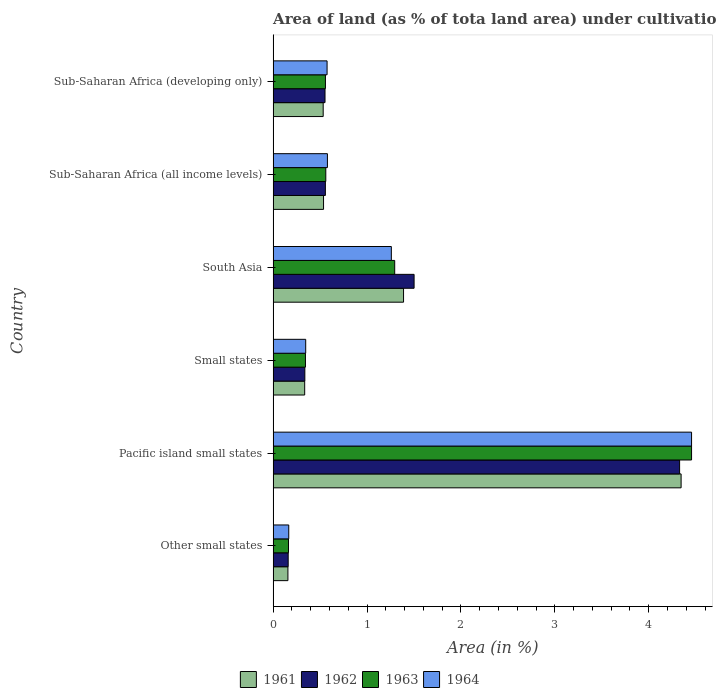How many different coloured bars are there?
Your response must be concise. 4. How many bars are there on the 6th tick from the bottom?
Offer a terse response. 4. What is the label of the 5th group of bars from the top?
Keep it short and to the point. Pacific island small states. What is the percentage of land under cultivation in 1962 in Other small states?
Your response must be concise. 0.16. Across all countries, what is the maximum percentage of land under cultivation in 1963?
Give a very brief answer. 4.46. Across all countries, what is the minimum percentage of land under cultivation in 1961?
Your answer should be very brief. 0.16. In which country was the percentage of land under cultivation in 1961 maximum?
Offer a terse response. Pacific island small states. In which country was the percentage of land under cultivation in 1964 minimum?
Your answer should be compact. Other small states. What is the total percentage of land under cultivation in 1961 in the graph?
Make the answer very short. 7.3. What is the difference between the percentage of land under cultivation in 1964 in Pacific island small states and that in Small states?
Make the answer very short. 4.11. What is the difference between the percentage of land under cultivation in 1961 in Sub-Saharan Africa (all income levels) and the percentage of land under cultivation in 1963 in Other small states?
Your answer should be compact. 0.37. What is the average percentage of land under cultivation in 1964 per country?
Offer a very short reply. 1.23. What is the difference between the percentage of land under cultivation in 1964 and percentage of land under cultivation in 1961 in Sub-Saharan Africa (all income levels)?
Provide a succinct answer. 0.04. What is the ratio of the percentage of land under cultivation in 1964 in Other small states to that in Pacific island small states?
Offer a terse response. 0.04. Is the percentage of land under cultivation in 1964 in Pacific island small states less than that in South Asia?
Ensure brevity in your answer.  No. What is the difference between the highest and the second highest percentage of land under cultivation in 1961?
Give a very brief answer. 2.96. What is the difference between the highest and the lowest percentage of land under cultivation in 1964?
Offer a very short reply. 4.29. In how many countries, is the percentage of land under cultivation in 1962 greater than the average percentage of land under cultivation in 1962 taken over all countries?
Provide a short and direct response. 2. What does the 4th bar from the top in Pacific island small states represents?
Offer a very short reply. 1961. What does the 2nd bar from the bottom in Small states represents?
Provide a short and direct response. 1962. Is it the case that in every country, the sum of the percentage of land under cultivation in 1964 and percentage of land under cultivation in 1963 is greater than the percentage of land under cultivation in 1961?
Your answer should be compact. Yes. How many bars are there?
Provide a short and direct response. 24. Are all the bars in the graph horizontal?
Keep it short and to the point. Yes. How many countries are there in the graph?
Give a very brief answer. 6. What is the difference between two consecutive major ticks on the X-axis?
Provide a short and direct response. 1. Are the values on the major ticks of X-axis written in scientific E-notation?
Provide a succinct answer. No. How many legend labels are there?
Give a very brief answer. 4. What is the title of the graph?
Your answer should be compact. Area of land (as % of tota land area) under cultivation. Does "1966" appear as one of the legend labels in the graph?
Give a very brief answer. No. What is the label or title of the X-axis?
Your answer should be very brief. Area (in %). What is the label or title of the Y-axis?
Ensure brevity in your answer.  Country. What is the Area (in %) of 1961 in Other small states?
Offer a very short reply. 0.16. What is the Area (in %) in 1962 in Other small states?
Provide a short and direct response. 0.16. What is the Area (in %) in 1963 in Other small states?
Offer a very short reply. 0.16. What is the Area (in %) in 1964 in Other small states?
Provide a succinct answer. 0.17. What is the Area (in %) in 1961 in Pacific island small states?
Provide a succinct answer. 4.34. What is the Area (in %) of 1962 in Pacific island small states?
Your response must be concise. 4.33. What is the Area (in %) in 1963 in Pacific island small states?
Give a very brief answer. 4.46. What is the Area (in %) in 1964 in Pacific island small states?
Provide a succinct answer. 4.46. What is the Area (in %) of 1961 in Small states?
Provide a short and direct response. 0.34. What is the Area (in %) in 1962 in Small states?
Offer a very short reply. 0.34. What is the Area (in %) in 1963 in Small states?
Give a very brief answer. 0.34. What is the Area (in %) of 1964 in Small states?
Provide a succinct answer. 0.35. What is the Area (in %) in 1961 in South Asia?
Offer a very short reply. 1.39. What is the Area (in %) of 1962 in South Asia?
Make the answer very short. 1.5. What is the Area (in %) in 1963 in South Asia?
Keep it short and to the point. 1.29. What is the Area (in %) of 1964 in South Asia?
Make the answer very short. 1.26. What is the Area (in %) in 1961 in Sub-Saharan Africa (all income levels)?
Keep it short and to the point. 0.54. What is the Area (in %) of 1962 in Sub-Saharan Africa (all income levels)?
Your answer should be compact. 0.56. What is the Area (in %) in 1963 in Sub-Saharan Africa (all income levels)?
Make the answer very short. 0.56. What is the Area (in %) of 1964 in Sub-Saharan Africa (all income levels)?
Offer a very short reply. 0.58. What is the Area (in %) of 1961 in Sub-Saharan Africa (developing only)?
Ensure brevity in your answer.  0.53. What is the Area (in %) in 1962 in Sub-Saharan Africa (developing only)?
Make the answer very short. 0.55. What is the Area (in %) in 1963 in Sub-Saharan Africa (developing only)?
Give a very brief answer. 0.56. What is the Area (in %) in 1964 in Sub-Saharan Africa (developing only)?
Your answer should be compact. 0.57. Across all countries, what is the maximum Area (in %) of 1961?
Make the answer very short. 4.34. Across all countries, what is the maximum Area (in %) of 1962?
Provide a succinct answer. 4.33. Across all countries, what is the maximum Area (in %) in 1963?
Make the answer very short. 4.46. Across all countries, what is the maximum Area (in %) in 1964?
Your answer should be compact. 4.46. Across all countries, what is the minimum Area (in %) of 1961?
Keep it short and to the point. 0.16. Across all countries, what is the minimum Area (in %) of 1962?
Keep it short and to the point. 0.16. Across all countries, what is the minimum Area (in %) of 1963?
Your answer should be very brief. 0.16. Across all countries, what is the minimum Area (in %) of 1964?
Give a very brief answer. 0.17. What is the total Area (in %) of 1961 in the graph?
Your answer should be compact. 7.3. What is the total Area (in %) in 1962 in the graph?
Offer a terse response. 7.44. What is the total Area (in %) in 1963 in the graph?
Offer a terse response. 7.38. What is the total Area (in %) of 1964 in the graph?
Keep it short and to the point. 7.38. What is the difference between the Area (in %) of 1961 in Other small states and that in Pacific island small states?
Your answer should be very brief. -4.19. What is the difference between the Area (in %) of 1962 in Other small states and that in Pacific island small states?
Provide a short and direct response. -4.17. What is the difference between the Area (in %) in 1963 in Other small states and that in Pacific island small states?
Your response must be concise. -4.29. What is the difference between the Area (in %) of 1964 in Other small states and that in Pacific island small states?
Give a very brief answer. -4.29. What is the difference between the Area (in %) of 1961 in Other small states and that in Small states?
Offer a very short reply. -0.18. What is the difference between the Area (in %) of 1962 in Other small states and that in Small states?
Give a very brief answer. -0.18. What is the difference between the Area (in %) in 1963 in Other small states and that in Small states?
Your answer should be very brief. -0.18. What is the difference between the Area (in %) in 1964 in Other small states and that in Small states?
Offer a terse response. -0.18. What is the difference between the Area (in %) of 1961 in Other small states and that in South Asia?
Keep it short and to the point. -1.23. What is the difference between the Area (in %) of 1962 in Other small states and that in South Asia?
Your answer should be very brief. -1.34. What is the difference between the Area (in %) in 1963 in Other small states and that in South Asia?
Your answer should be very brief. -1.13. What is the difference between the Area (in %) of 1964 in Other small states and that in South Asia?
Keep it short and to the point. -1.09. What is the difference between the Area (in %) in 1961 in Other small states and that in Sub-Saharan Africa (all income levels)?
Ensure brevity in your answer.  -0.38. What is the difference between the Area (in %) of 1962 in Other small states and that in Sub-Saharan Africa (all income levels)?
Make the answer very short. -0.4. What is the difference between the Area (in %) of 1963 in Other small states and that in Sub-Saharan Africa (all income levels)?
Offer a very short reply. -0.4. What is the difference between the Area (in %) of 1964 in Other small states and that in Sub-Saharan Africa (all income levels)?
Your answer should be compact. -0.41. What is the difference between the Area (in %) of 1961 in Other small states and that in Sub-Saharan Africa (developing only)?
Offer a terse response. -0.38. What is the difference between the Area (in %) of 1962 in Other small states and that in Sub-Saharan Africa (developing only)?
Your response must be concise. -0.39. What is the difference between the Area (in %) of 1963 in Other small states and that in Sub-Saharan Africa (developing only)?
Your answer should be compact. -0.39. What is the difference between the Area (in %) of 1964 in Other small states and that in Sub-Saharan Africa (developing only)?
Provide a succinct answer. -0.41. What is the difference between the Area (in %) in 1961 in Pacific island small states and that in Small states?
Provide a short and direct response. 4.01. What is the difference between the Area (in %) of 1962 in Pacific island small states and that in Small states?
Make the answer very short. 3.99. What is the difference between the Area (in %) of 1963 in Pacific island small states and that in Small states?
Ensure brevity in your answer.  4.11. What is the difference between the Area (in %) in 1964 in Pacific island small states and that in Small states?
Make the answer very short. 4.11. What is the difference between the Area (in %) in 1961 in Pacific island small states and that in South Asia?
Your response must be concise. 2.96. What is the difference between the Area (in %) in 1962 in Pacific island small states and that in South Asia?
Your response must be concise. 2.83. What is the difference between the Area (in %) in 1963 in Pacific island small states and that in South Asia?
Your answer should be very brief. 3.16. What is the difference between the Area (in %) in 1964 in Pacific island small states and that in South Asia?
Your response must be concise. 3.2. What is the difference between the Area (in %) in 1961 in Pacific island small states and that in Sub-Saharan Africa (all income levels)?
Offer a very short reply. 3.81. What is the difference between the Area (in %) in 1962 in Pacific island small states and that in Sub-Saharan Africa (all income levels)?
Provide a short and direct response. 3.77. What is the difference between the Area (in %) of 1963 in Pacific island small states and that in Sub-Saharan Africa (all income levels)?
Ensure brevity in your answer.  3.89. What is the difference between the Area (in %) in 1964 in Pacific island small states and that in Sub-Saharan Africa (all income levels)?
Keep it short and to the point. 3.88. What is the difference between the Area (in %) of 1961 in Pacific island small states and that in Sub-Saharan Africa (developing only)?
Your answer should be very brief. 3.81. What is the difference between the Area (in %) in 1962 in Pacific island small states and that in Sub-Saharan Africa (developing only)?
Give a very brief answer. 3.78. What is the difference between the Area (in %) in 1963 in Pacific island small states and that in Sub-Saharan Africa (developing only)?
Make the answer very short. 3.9. What is the difference between the Area (in %) of 1964 in Pacific island small states and that in Sub-Saharan Africa (developing only)?
Offer a very short reply. 3.88. What is the difference between the Area (in %) of 1961 in Small states and that in South Asia?
Provide a succinct answer. -1.05. What is the difference between the Area (in %) of 1962 in Small states and that in South Asia?
Offer a terse response. -1.16. What is the difference between the Area (in %) in 1963 in Small states and that in South Asia?
Ensure brevity in your answer.  -0.95. What is the difference between the Area (in %) of 1964 in Small states and that in South Asia?
Your answer should be very brief. -0.91. What is the difference between the Area (in %) of 1961 in Small states and that in Sub-Saharan Africa (all income levels)?
Offer a terse response. -0.2. What is the difference between the Area (in %) in 1962 in Small states and that in Sub-Saharan Africa (all income levels)?
Your answer should be compact. -0.22. What is the difference between the Area (in %) in 1963 in Small states and that in Sub-Saharan Africa (all income levels)?
Your response must be concise. -0.22. What is the difference between the Area (in %) of 1964 in Small states and that in Sub-Saharan Africa (all income levels)?
Give a very brief answer. -0.23. What is the difference between the Area (in %) of 1961 in Small states and that in Sub-Saharan Africa (developing only)?
Your answer should be very brief. -0.2. What is the difference between the Area (in %) of 1962 in Small states and that in Sub-Saharan Africa (developing only)?
Make the answer very short. -0.21. What is the difference between the Area (in %) in 1963 in Small states and that in Sub-Saharan Africa (developing only)?
Keep it short and to the point. -0.21. What is the difference between the Area (in %) of 1964 in Small states and that in Sub-Saharan Africa (developing only)?
Your answer should be compact. -0.23. What is the difference between the Area (in %) in 1961 in South Asia and that in Sub-Saharan Africa (all income levels)?
Offer a terse response. 0.85. What is the difference between the Area (in %) of 1962 in South Asia and that in Sub-Saharan Africa (all income levels)?
Provide a succinct answer. 0.94. What is the difference between the Area (in %) of 1963 in South Asia and that in Sub-Saharan Africa (all income levels)?
Ensure brevity in your answer.  0.73. What is the difference between the Area (in %) of 1964 in South Asia and that in Sub-Saharan Africa (all income levels)?
Your answer should be very brief. 0.68. What is the difference between the Area (in %) of 1961 in South Asia and that in Sub-Saharan Africa (developing only)?
Offer a terse response. 0.86. What is the difference between the Area (in %) in 1962 in South Asia and that in Sub-Saharan Africa (developing only)?
Offer a terse response. 0.95. What is the difference between the Area (in %) in 1963 in South Asia and that in Sub-Saharan Africa (developing only)?
Offer a very short reply. 0.74. What is the difference between the Area (in %) of 1964 in South Asia and that in Sub-Saharan Africa (developing only)?
Ensure brevity in your answer.  0.68. What is the difference between the Area (in %) of 1961 in Sub-Saharan Africa (all income levels) and that in Sub-Saharan Africa (developing only)?
Provide a succinct answer. 0. What is the difference between the Area (in %) of 1962 in Sub-Saharan Africa (all income levels) and that in Sub-Saharan Africa (developing only)?
Your answer should be very brief. 0. What is the difference between the Area (in %) of 1963 in Sub-Saharan Africa (all income levels) and that in Sub-Saharan Africa (developing only)?
Provide a succinct answer. 0. What is the difference between the Area (in %) of 1964 in Sub-Saharan Africa (all income levels) and that in Sub-Saharan Africa (developing only)?
Your response must be concise. 0. What is the difference between the Area (in %) in 1961 in Other small states and the Area (in %) in 1962 in Pacific island small states?
Offer a very short reply. -4.17. What is the difference between the Area (in %) of 1961 in Other small states and the Area (in %) of 1963 in Pacific island small states?
Make the answer very short. -4.3. What is the difference between the Area (in %) of 1961 in Other small states and the Area (in %) of 1964 in Pacific island small states?
Provide a succinct answer. -4.3. What is the difference between the Area (in %) in 1962 in Other small states and the Area (in %) in 1963 in Pacific island small states?
Provide a succinct answer. -4.3. What is the difference between the Area (in %) of 1962 in Other small states and the Area (in %) of 1964 in Pacific island small states?
Your answer should be very brief. -4.3. What is the difference between the Area (in %) of 1963 in Other small states and the Area (in %) of 1964 in Pacific island small states?
Make the answer very short. -4.29. What is the difference between the Area (in %) of 1961 in Other small states and the Area (in %) of 1962 in Small states?
Give a very brief answer. -0.18. What is the difference between the Area (in %) of 1961 in Other small states and the Area (in %) of 1963 in Small states?
Keep it short and to the point. -0.19. What is the difference between the Area (in %) of 1961 in Other small states and the Area (in %) of 1964 in Small states?
Your answer should be compact. -0.19. What is the difference between the Area (in %) of 1962 in Other small states and the Area (in %) of 1963 in Small states?
Offer a very short reply. -0.18. What is the difference between the Area (in %) in 1962 in Other small states and the Area (in %) in 1964 in Small states?
Provide a short and direct response. -0.19. What is the difference between the Area (in %) in 1963 in Other small states and the Area (in %) in 1964 in Small states?
Your response must be concise. -0.18. What is the difference between the Area (in %) of 1961 in Other small states and the Area (in %) of 1962 in South Asia?
Provide a short and direct response. -1.34. What is the difference between the Area (in %) of 1961 in Other small states and the Area (in %) of 1963 in South Asia?
Your answer should be very brief. -1.14. What is the difference between the Area (in %) of 1961 in Other small states and the Area (in %) of 1964 in South Asia?
Make the answer very short. -1.1. What is the difference between the Area (in %) of 1962 in Other small states and the Area (in %) of 1963 in South Asia?
Keep it short and to the point. -1.13. What is the difference between the Area (in %) in 1962 in Other small states and the Area (in %) in 1964 in South Asia?
Make the answer very short. -1.1. What is the difference between the Area (in %) in 1963 in Other small states and the Area (in %) in 1964 in South Asia?
Provide a succinct answer. -1.1. What is the difference between the Area (in %) in 1961 in Other small states and the Area (in %) in 1962 in Sub-Saharan Africa (all income levels)?
Offer a very short reply. -0.4. What is the difference between the Area (in %) in 1961 in Other small states and the Area (in %) in 1963 in Sub-Saharan Africa (all income levels)?
Your response must be concise. -0.4. What is the difference between the Area (in %) in 1961 in Other small states and the Area (in %) in 1964 in Sub-Saharan Africa (all income levels)?
Your answer should be compact. -0.42. What is the difference between the Area (in %) of 1962 in Other small states and the Area (in %) of 1963 in Sub-Saharan Africa (all income levels)?
Give a very brief answer. -0.4. What is the difference between the Area (in %) of 1962 in Other small states and the Area (in %) of 1964 in Sub-Saharan Africa (all income levels)?
Provide a succinct answer. -0.42. What is the difference between the Area (in %) in 1963 in Other small states and the Area (in %) in 1964 in Sub-Saharan Africa (all income levels)?
Provide a succinct answer. -0.41. What is the difference between the Area (in %) in 1961 in Other small states and the Area (in %) in 1962 in Sub-Saharan Africa (developing only)?
Provide a succinct answer. -0.4. What is the difference between the Area (in %) in 1961 in Other small states and the Area (in %) in 1963 in Sub-Saharan Africa (developing only)?
Provide a succinct answer. -0.4. What is the difference between the Area (in %) in 1961 in Other small states and the Area (in %) in 1964 in Sub-Saharan Africa (developing only)?
Make the answer very short. -0.42. What is the difference between the Area (in %) of 1962 in Other small states and the Area (in %) of 1963 in Sub-Saharan Africa (developing only)?
Your response must be concise. -0.4. What is the difference between the Area (in %) of 1962 in Other small states and the Area (in %) of 1964 in Sub-Saharan Africa (developing only)?
Make the answer very short. -0.41. What is the difference between the Area (in %) in 1963 in Other small states and the Area (in %) in 1964 in Sub-Saharan Africa (developing only)?
Make the answer very short. -0.41. What is the difference between the Area (in %) of 1961 in Pacific island small states and the Area (in %) of 1962 in Small states?
Give a very brief answer. 4.01. What is the difference between the Area (in %) of 1961 in Pacific island small states and the Area (in %) of 1963 in Small states?
Ensure brevity in your answer.  4. What is the difference between the Area (in %) of 1961 in Pacific island small states and the Area (in %) of 1964 in Small states?
Give a very brief answer. 4. What is the difference between the Area (in %) of 1962 in Pacific island small states and the Area (in %) of 1963 in Small states?
Give a very brief answer. 3.98. What is the difference between the Area (in %) of 1962 in Pacific island small states and the Area (in %) of 1964 in Small states?
Offer a very short reply. 3.98. What is the difference between the Area (in %) in 1963 in Pacific island small states and the Area (in %) in 1964 in Small states?
Keep it short and to the point. 4.11. What is the difference between the Area (in %) of 1961 in Pacific island small states and the Area (in %) of 1962 in South Asia?
Your answer should be very brief. 2.84. What is the difference between the Area (in %) in 1961 in Pacific island small states and the Area (in %) in 1963 in South Asia?
Offer a terse response. 3.05. What is the difference between the Area (in %) in 1961 in Pacific island small states and the Area (in %) in 1964 in South Asia?
Provide a short and direct response. 3.09. What is the difference between the Area (in %) of 1962 in Pacific island small states and the Area (in %) of 1963 in South Asia?
Offer a terse response. 3.03. What is the difference between the Area (in %) in 1962 in Pacific island small states and the Area (in %) in 1964 in South Asia?
Provide a short and direct response. 3.07. What is the difference between the Area (in %) of 1963 in Pacific island small states and the Area (in %) of 1964 in South Asia?
Your answer should be compact. 3.2. What is the difference between the Area (in %) of 1961 in Pacific island small states and the Area (in %) of 1962 in Sub-Saharan Africa (all income levels)?
Your answer should be very brief. 3.79. What is the difference between the Area (in %) in 1961 in Pacific island small states and the Area (in %) in 1963 in Sub-Saharan Africa (all income levels)?
Your answer should be very brief. 3.78. What is the difference between the Area (in %) in 1961 in Pacific island small states and the Area (in %) in 1964 in Sub-Saharan Africa (all income levels)?
Provide a succinct answer. 3.77. What is the difference between the Area (in %) of 1962 in Pacific island small states and the Area (in %) of 1963 in Sub-Saharan Africa (all income levels)?
Your response must be concise. 3.77. What is the difference between the Area (in %) in 1962 in Pacific island small states and the Area (in %) in 1964 in Sub-Saharan Africa (all income levels)?
Your response must be concise. 3.75. What is the difference between the Area (in %) in 1963 in Pacific island small states and the Area (in %) in 1964 in Sub-Saharan Africa (all income levels)?
Provide a short and direct response. 3.88. What is the difference between the Area (in %) of 1961 in Pacific island small states and the Area (in %) of 1962 in Sub-Saharan Africa (developing only)?
Provide a succinct answer. 3.79. What is the difference between the Area (in %) in 1961 in Pacific island small states and the Area (in %) in 1963 in Sub-Saharan Africa (developing only)?
Make the answer very short. 3.79. What is the difference between the Area (in %) of 1961 in Pacific island small states and the Area (in %) of 1964 in Sub-Saharan Africa (developing only)?
Ensure brevity in your answer.  3.77. What is the difference between the Area (in %) in 1962 in Pacific island small states and the Area (in %) in 1963 in Sub-Saharan Africa (developing only)?
Make the answer very short. 3.77. What is the difference between the Area (in %) of 1962 in Pacific island small states and the Area (in %) of 1964 in Sub-Saharan Africa (developing only)?
Make the answer very short. 3.75. What is the difference between the Area (in %) in 1963 in Pacific island small states and the Area (in %) in 1964 in Sub-Saharan Africa (developing only)?
Offer a terse response. 3.88. What is the difference between the Area (in %) in 1961 in Small states and the Area (in %) in 1962 in South Asia?
Your response must be concise. -1.17. What is the difference between the Area (in %) of 1961 in Small states and the Area (in %) of 1963 in South Asia?
Provide a short and direct response. -0.96. What is the difference between the Area (in %) of 1961 in Small states and the Area (in %) of 1964 in South Asia?
Offer a terse response. -0.92. What is the difference between the Area (in %) of 1962 in Small states and the Area (in %) of 1963 in South Asia?
Make the answer very short. -0.96. What is the difference between the Area (in %) in 1962 in Small states and the Area (in %) in 1964 in South Asia?
Make the answer very short. -0.92. What is the difference between the Area (in %) in 1963 in Small states and the Area (in %) in 1964 in South Asia?
Keep it short and to the point. -0.91. What is the difference between the Area (in %) in 1961 in Small states and the Area (in %) in 1962 in Sub-Saharan Africa (all income levels)?
Offer a terse response. -0.22. What is the difference between the Area (in %) in 1961 in Small states and the Area (in %) in 1963 in Sub-Saharan Africa (all income levels)?
Offer a terse response. -0.22. What is the difference between the Area (in %) of 1961 in Small states and the Area (in %) of 1964 in Sub-Saharan Africa (all income levels)?
Ensure brevity in your answer.  -0.24. What is the difference between the Area (in %) of 1962 in Small states and the Area (in %) of 1963 in Sub-Saharan Africa (all income levels)?
Your answer should be very brief. -0.22. What is the difference between the Area (in %) of 1962 in Small states and the Area (in %) of 1964 in Sub-Saharan Africa (all income levels)?
Give a very brief answer. -0.24. What is the difference between the Area (in %) of 1963 in Small states and the Area (in %) of 1964 in Sub-Saharan Africa (all income levels)?
Offer a very short reply. -0.23. What is the difference between the Area (in %) of 1961 in Small states and the Area (in %) of 1962 in Sub-Saharan Africa (developing only)?
Ensure brevity in your answer.  -0.22. What is the difference between the Area (in %) in 1961 in Small states and the Area (in %) in 1963 in Sub-Saharan Africa (developing only)?
Your answer should be compact. -0.22. What is the difference between the Area (in %) in 1961 in Small states and the Area (in %) in 1964 in Sub-Saharan Africa (developing only)?
Your response must be concise. -0.24. What is the difference between the Area (in %) in 1962 in Small states and the Area (in %) in 1963 in Sub-Saharan Africa (developing only)?
Make the answer very short. -0.22. What is the difference between the Area (in %) of 1962 in Small states and the Area (in %) of 1964 in Sub-Saharan Africa (developing only)?
Give a very brief answer. -0.24. What is the difference between the Area (in %) of 1963 in Small states and the Area (in %) of 1964 in Sub-Saharan Africa (developing only)?
Your answer should be very brief. -0.23. What is the difference between the Area (in %) in 1961 in South Asia and the Area (in %) in 1962 in Sub-Saharan Africa (all income levels)?
Ensure brevity in your answer.  0.83. What is the difference between the Area (in %) in 1961 in South Asia and the Area (in %) in 1963 in Sub-Saharan Africa (all income levels)?
Keep it short and to the point. 0.83. What is the difference between the Area (in %) of 1961 in South Asia and the Area (in %) of 1964 in Sub-Saharan Africa (all income levels)?
Your response must be concise. 0.81. What is the difference between the Area (in %) in 1962 in South Asia and the Area (in %) in 1963 in Sub-Saharan Africa (all income levels)?
Your response must be concise. 0.94. What is the difference between the Area (in %) of 1962 in South Asia and the Area (in %) of 1964 in Sub-Saharan Africa (all income levels)?
Your response must be concise. 0.92. What is the difference between the Area (in %) in 1963 in South Asia and the Area (in %) in 1964 in Sub-Saharan Africa (all income levels)?
Your response must be concise. 0.72. What is the difference between the Area (in %) of 1961 in South Asia and the Area (in %) of 1962 in Sub-Saharan Africa (developing only)?
Make the answer very short. 0.84. What is the difference between the Area (in %) of 1961 in South Asia and the Area (in %) of 1963 in Sub-Saharan Africa (developing only)?
Provide a short and direct response. 0.83. What is the difference between the Area (in %) in 1961 in South Asia and the Area (in %) in 1964 in Sub-Saharan Africa (developing only)?
Ensure brevity in your answer.  0.81. What is the difference between the Area (in %) in 1962 in South Asia and the Area (in %) in 1963 in Sub-Saharan Africa (developing only)?
Provide a succinct answer. 0.94. What is the difference between the Area (in %) in 1962 in South Asia and the Area (in %) in 1964 in Sub-Saharan Africa (developing only)?
Offer a very short reply. 0.93. What is the difference between the Area (in %) in 1963 in South Asia and the Area (in %) in 1964 in Sub-Saharan Africa (developing only)?
Make the answer very short. 0.72. What is the difference between the Area (in %) in 1961 in Sub-Saharan Africa (all income levels) and the Area (in %) in 1962 in Sub-Saharan Africa (developing only)?
Offer a terse response. -0.02. What is the difference between the Area (in %) of 1961 in Sub-Saharan Africa (all income levels) and the Area (in %) of 1963 in Sub-Saharan Africa (developing only)?
Give a very brief answer. -0.02. What is the difference between the Area (in %) of 1961 in Sub-Saharan Africa (all income levels) and the Area (in %) of 1964 in Sub-Saharan Africa (developing only)?
Make the answer very short. -0.04. What is the difference between the Area (in %) in 1962 in Sub-Saharan Africa (all income levels) and the Area (in %) in 1963 in Sub-Saharan Africa (developing only)?
Provide a succinct answer. -0. What is the difference between the Area (in %) in 1962 in Sub-Saharan Africa (all income levels) and the Area (in %) in 1964 in Sub-Saharan Africa (developing only)?
Ensure brevity in your answer.  -0.02. What is the difference between the Area (in %) of 1963 in Sub-Saharan Africa (all income levels) and the Area (in %) of 1964 in Sub-Saharan Africa (developing only)?
Your answer should be compact. -0.01. What is the average Area (in %) in 1961 per country?
Make the answer very short. 1.22. What is the average Area (in %) of 1962 per country?
Provide a short and direct response. 1.24. What is the average Area (in %) of 1963 per country?
Give a very brief answer. 1.23. What is the average Area (in %) of 1964 per country?
Provide a succinct answer. 1.23. What is the difference between the Area (in %) of 1961 and Area (in %) of 1962 in Other small states?
Give a very brief answer. -0. What is the difference between the Area (in %) in 1961 and Area (in %) in 1963 in Other small states?
Your response must be concise. -0.01. What is the difference between the Area (in %) in 1961 and Area (in %) in 1964 in Other small states?
Your response must be concise. -0.01. What is the difference between the Area (in %) in 1962 and Area (in %) in 1963 in Other small states?
Offer a terse response. -0. What is the difference between the Area (in %) of 1962 and Area (in %) of 1964 in Other small states?
Your answer should be compact. -0.01. What is the difference between the Area (in %) in 1963 and Area (in %) in 1964 in Other small states?
Provide a short and direct response. -0. What is the difference between the Area (in %) in 1961 and Area (in %) in 1962 in Pacific island small states?
Offer a very short reply. 0.02. What is the difference between the Area (in %) in 1961 and Area (in %) in 1963 in Pacific island small states?
Ensure brevity in your answer.  -0.11. What is the difference between the Area (in %) in 1961 and Area (in %) in 1964 in Pacific island small states?
Keep it short and to the point. -0.11. What is the difference between the Area (in %) in 1962 and Area (in %) in 1963 in Pacific island small states?
Keep it short and to the point. -0.13. What is the difference between the Area (in %) of 1962 and Area (in %) of 1964 in Pacific island small states?
Provide a succinct answer. -0.13. What is the difference between the Area (in %) of 1963 and Area (in %) of 1964 in Pacific island small states?
Keep it short and to the point. 0. What is the difference between the Area (in %) in 1961 and Area (in %) in 1962 in Small states?
Give a very brief answer. -0. What is the difference between the Area (in %) of 1961 and Area (in %) of 1963 in Small states?
Provide a succinct answer. -0.01. What is the difference between the Area (in %) in 1961 and Area (in %) in 1964 in Small states?
Offer a very short reply. -0.01. What is the difference between the Area (in %) in 1962 and Area (in %) in 1963 in Small states?
Provide a succinct answer. -0.01. What is the difference between the Area (in %) in 1962 and Area (in %) in 1964 in Small states?
Make the answer very short. -0.01. What is the difference between the Area (in %) in 1963 and Area (in %) in 1964 in Small states?
Provide a short and direct response. -0. What is the difference between the Area (in %) in 1961 and Area (in %) in 1962 in South Asia?
Keep it short and to the point. -0.11. What is the difference between the Area (in %) in 1961 and Area (in %) in 1963 in South Asia?
Provide a short and direct response. 0.09. What is the difference between the Area (in %) in 1961 and Area (in %) in 1964 in South Asia?
Offer a very short reply. 0.13. What is the difference between the Area (in %) in 1962 and Area (in %) in 1963 in South Asia?
Make the answer very short. 0.21. What is the difference between the Area (in %) of 1962 and Area (in %) of 1964 in South Asia?
Your answer should be very brief. 0.24. What is the difference between the Area (in %) in 1963 and Area (in %) in 1964 in South Asia?
Keep it short and to the point. 0.04. What is the difference between the Area (in %) in 1961 and Area (in %) in 1962 in Sub-Saharan Africa (all income levels)?
Provide a succinct answer. -0.02. What is the difference between the Area (in %) of 1961 and Area (in %) of 1963 in Sub-Saharan Africa (all income levels)?
Keep it short and to the point. -0.02. What is the difference between the Area (in %) in 1961 and Area (in %) in 1964 in Sub-Saharan Africa (all income levels)?
Ensure brevity in your answer.  -0.04. What is the difference between the Area (in %) in 1962 and Area (in %) in 1963 in Sub-Saharan Africa (all income levels)?
Keep it short and to the point. -0. What is the difference between the Area (in %) in 1962 and Area (in %) in 1964 in Sub-Saharan Africa (all income levels)?
Ensure brevity in your answer.  -0.02. What is the difference between the Area (in %) of 1963 and Area (in %) of 1964 in Sub-Saharan Africa (all income levels)?
Keep it short and to the point. -0.02. What is the difference between the Area (in %) in 1961 and Area (in %) in 1962 in Sub-Saharan Africa (developing only)?
Make the answer very short. -0.02. What is the difference between the Area (in %) of 1961 and Area (in %) of 1963 in Sub-Saharan Africa (developing only)?
Give a very brief answer. -0.02. What is the difference between the Area (in %) in 1961 and Area (in %) in 1964 in Sub-Saharan Africa (developing only)?
Offer a terse response. -0.04. What is the difference between the Area (in %) of 1962 and Area (in %) of 1963 in Sub-Saharan Africa (developing only)?
Your response must be concise. -0. What is the difference between the Area (in %) of 1962 and Area (in %) of 1964 in Sub-Saharan Africa (developing only)?
Offer a very short reply. -0.02. What is the difference between the Area (in %) of 1963 and Area (in %) of 1964 in Sub-Saharan Africa (developing only)?
Your response must be concise. -0.02. What is the ratio of the Area (in %) of 1961 in Other small states to that in Pacific island small states?
Offer a terse response. 0.04. What is the ratio of the Area (in %) of 1962 in Other small states to that in Pacific island small states?
Offer a terse response. 0.04. What is the ratio of the Area (in %) in 1963 in Other small states to that in Pacific island small states?
Ensure brevity in your answer.  0.04. What is the ratio of the Area (in %) in 1964 in Other small states to that in Pacific island small states?
Offer a very short reply. 0.04. What is the ratio of the Area (in %) of 1961 in Other small states to that in Small states?
Your response must be concise. 0.47. What is the ratio of the Area (in %) of 1962 in Other small states to that in Small states?
Offer a terse response. 0.47. What is the ratio of the Area (in %) in 1963 in Other small states to that in Small states?
Keep it short and to the point. 0.48. What is the ratio of the Area (in %) in 1964 in Other small states to that in Small states?
Give a very brief answer. 0.48. What is the ratio of the Area (in %) of 1961 in Other small states to that in South Asia?
Offer a terse response. 0.11. What is the ratio of the Area (in %) in 1962 in Other small states to that in South Asia?
Provide a succinct answer. 0.11. What is the ratio of the Area (in %) in 1963 in Other small states to that in South Asia?
Give a very brief answer. 0.13. What is the ratio of the Area (in %) in 1964 in Other small states to that in South Asia?
Offer a terse response. 0.13. What is the ratio of the Area (in %) of 1961 in Other small states to that in Sub-Saharan Africa (all income levels)?
Provide a short and direct response. 0.29. What is the ratio of the Area (in %) in 1962 in Other small states to that in Sub-Saharan Africa (all income levels)?
Provide a succinct answer. 0.29. What is the ratio of the Area (in %) in 1963 in Other small states to that in Sub-Saharan Africa (all income levels)?
Offer a very short reply. 0.29. What is the ratio of the Area (in %) in 1964 in Other small states to that in Sub-Saharan Africa (all income levels)?
Provide a short and direct response. 0.29. What is the ratio of the Area (in %) of 1961 in Other small states to that in Sub-Saharan Africa (developing only)?
Your answer should be compact. 0.3. What is the ratio of the Area (in %) of 1962 in Other small states to that in Sub-Saharan Africa (developing only)?
Provide a succinct answer. 0.29. What is the ratio of the Area (in %) in 1963 in Other small states to that in Sub-Saharan Africa (developing only)?
Offer a terse response. 0.29. What is the ratio of the Area (in %) of 1964 in Other small states to that in Sub-Saharan Africa (developing only)?
Offer a terse response. 0.29. What is the ratio of the Area (in %) of 1961 in Pacific island small states to that in Small states?
Your response must be concise. 12.93. What is the ratio of the Area (in %) in 1962 in Pacific island small states to that in Small states?
Give a very brief answer. 12.81. What is the ratio of the Area (in %) in 1963 in Pacific island small states to that in Small states?
Your response must be concise. 12.94. What is the ratio of the Area (in %) in 1964 in Pacific island small states to that in Small states?
Your answer should be compact. 12.84. What is the ratio of the Area (in %) in 1961 in Pacific island small states to that in South Asia?
Provide a succinct answer. 3.13. What is the ratio of the Area (in %) in 1962 in Pacific island small states to that in South Asia?
Your answer should be very brief. 2.88. What is the ratio of the Area (in %) of 1963 in Pacific island small states to that in South Asia?
Your answer should be very brief. 3.44. What is the ratio of the Area (in %) in 1964 in Pacific island small states to that in South Asia?
Provide a succinct answer. 3.54. What is the ratio of the Area (in %) in 1961 in Pacific island small states to that in Sub-Saharan Africa (all income levels)?
Provide a succinct answer. 8.09. What is the ratio of the Area (in %) of 1962 in Pacific island small states to that in Sub-Saharan Africa (all income levels)?
Provide a short and direct response. 7.78. What is the ratio of the Area (in %) in 1963 in Pacific island small states to that in Sub-Saharan Africa (all income levels)?
Offer a terse response. 7.94. What is the ratio of the Area (in %) of 1964 in Pacific island small states to that in Sub-Saharan Africa (all income levels)?
Your answer should be compact. 7.71. What is the ratio of the Area (in %) in 1961 in Pacific island small states to that in Sub-Saharan Africa (developing only)?
Ensure brevity in your answer.  8.15. What is the ratio of the Area (in %) of 1962 in Pacific island small states to that in Sub-Saharan Africa (developing only)?
Your response must be concise. 7.83. What is the ratio of the Area (in %) of 1963 in Pacific island small states to that in Sub-Saharan Africa (developing only)?
Provide a short and direct response. 8. What is the ratio of the Area (in %) of 1964 in Pacific island small states to that in Sub-Saharan Africa (developing only)?
Your response must be concise. 7.76. What is the ratio of the Area (in %) in 1961 in Small states to that in South Asia?
Offer a terse response. 0.24. What is the ratio of the Area (in %) in 1962 in Small states to that in South Asia?
Make the answer very short. 0.23. What is the ratio of the Area (in %) of 1963 in Small states to that in South Asia?
Ensure brevity in your answer.  0.27. What is the ratio of the Area (in %) of 1964 in Small states to that in South Asia?
Keep it short and to the point. 0.28. What is the ratio of the Area (in %) of 1961 in Small states to that in Sub-Saharan Africa (all income levels)?
Offer a terse response. 0.63. What is the ratio of the Area (in %) in 1962 in Small states to that in Sub-Saharan Africa (all income levels)?
Make the answer very short. 0.61. What is the ratio of the Area (in %) of 1963 in Small states to that in Sub-Saharan Africa (all income levels)?
Provide a short and direct response. 0.61. What is the ratio of the Area (in %) in 1961 in Small states to that in Sub-Saharan Africa (developing only)?
Provide a succinct answer. 0.63. What is the ratio of the Area (in %) of 1962 in Small states to that in Sub-Saharan Africa (developing only)?
Offer a very short reply. 0.61. What is the ratio of the Area (in %) of 1963 in Small states to that in Sub-Saharan Africa (developing only)?
Give a very brief answer. 0.62. What is the ratio of the Area (in %) of 1964 in Small states to that in Sub-Saharan Africa (developing only)?
Provide a succinct answer. 0.6. What is the ratio of the Area (in %) of 1961 in South Asia to that in Sub-Saharan Africa (all income levels)?
Keep it short and to the point. 2.59. What is the ratio of the Area (in %) of 1962 in South Asia to that in Sub-Saharan Africa (all income levels)?
Your answer should be compact. 2.7. What is the ratio of the Area (in %) of 1963 in South Asia to that in Sub-Saharan Africa (all income levels)?
Offer a terse response. 2.31. What is the ratio of the Area (in %) of 1964 in South Asia to that in Sub-Saharan Africa (all income levels)?
Provide a short and direct response. 2.18. What is the ratio of the Area (in %) in 1961 in South Asia to that in Sub-Saharan Africa (developing only)?
Provide a short and direct response. 2.6. What is the ratio of the Area (in %) in 1962 in South Asia to that in Sub-Saharan Africa (developing only)?
Your response must be concise. 2.72. What is the ratio of the Area (in %) of 1963 in South Asia to that in Sub-Saharan Africa (developing only)?
Your response must be concise. 2.32. What is the ratio of the Area (in %) in 1964 in South Asia to that in Sub-Saharan Africa (developing only)?
Offer a very short reply. 2.19. What is the ratio of the Area (in %) in 1961 in Sub-Saharan Africa (all income levels) to that in Sub-Saharan Africa (developing only)?
Keep it short and to the point. 1.01. What is the ratio of the Area (in %) of 1962 in Sub-Saharan Africa (all income levels) to that in Sub-Saharan Africa (developing only)?
Keep it short and to the point. 1.01. What is the ratio of the Area (in %) in 1963 in Sub-Saharan Africa (all income levels) to that in Sub-Saharan Africa (developing only)?
Provide a short and direct response. 1.01. What is the ratio of the Area (in %) in 1964 in Sub-Saharan Africa (all income levels) to that in Sub-Saharan Africa (developing only)?
Keep it short and to the point. 1.01. What is the difference between the highest and the second highest Area (in %) in 1961?
Your answer should be very brief. 2.96. What is the difference between the highest and the second highest Area (in %) in 1962?
Your answer should be compact. 2.83. What is the difference between the highest and the second highest Area (in %) in 1963?
Make the answer very short. 3.16. What is the difference between the highest and the second highest Area (in %) of 1964?
Your answer should be compact. 3.2. What is the difference between the highest and the lowest Area (in %) of 1961?
Give a very brief answer. 4.19. What is the difference between the highest and the lowest Area (in %) in 1962?
Your answer should be compact. 4.17. What is the difference between the highest and the lowest Area (in %) in 1963?
Provide a short and direct response. 4.29. What is the difference between the highest and the lowest Area (in %) in 1964?
Your response must be concise. 4.29. 